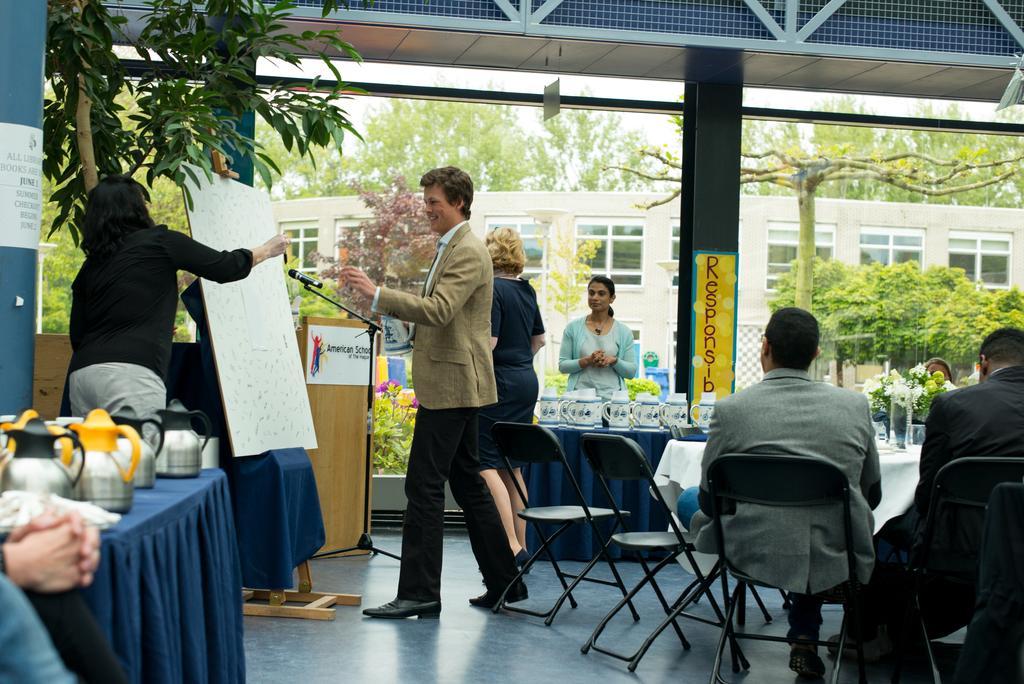In one or two sentences, can you explain what this image depicts? There is a woman and man standing at the board,behind it there is a table. On the left there is a table and kettles are over it and two women are standing at the table and two men are sitting on the chair. In the background there is a building,trees,window and sky. 